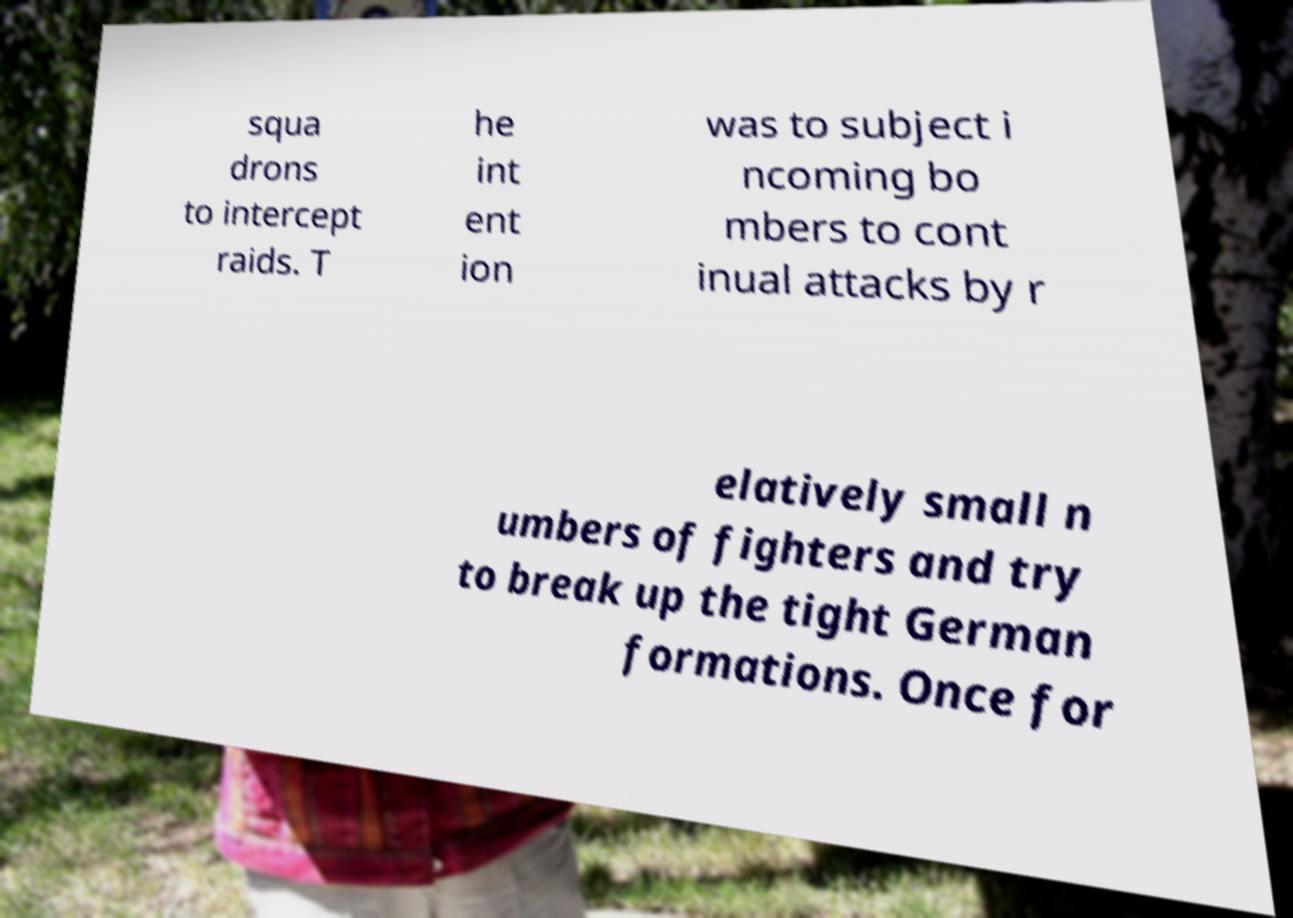I need the written content from this picture converted into text. Can you do that? squa drons to intercept raids. T he int ent ion was to subject i ncoming bo mbers to cont inual attacks by r elatively small n umbers of fighters and try to break up the tight German formations. Once for 